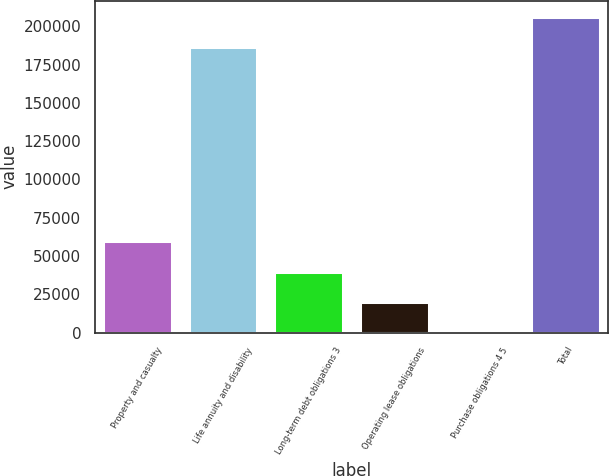<chart> <loc_0><loc_0><loc_500><loc_500><bar_chart><fcel>Property and casualty<fcel>Life annuity and disability<fcel>Long-term debt obligations 3<fcel>Operating lease obligations<fcel>Purchase obligations 4 5<fcel>Total<nl><fcel>59742.1<fcel>186388<fcel>39833.4<fcel>19924.7<fcel>16<fcel>206297<nl></chart> 